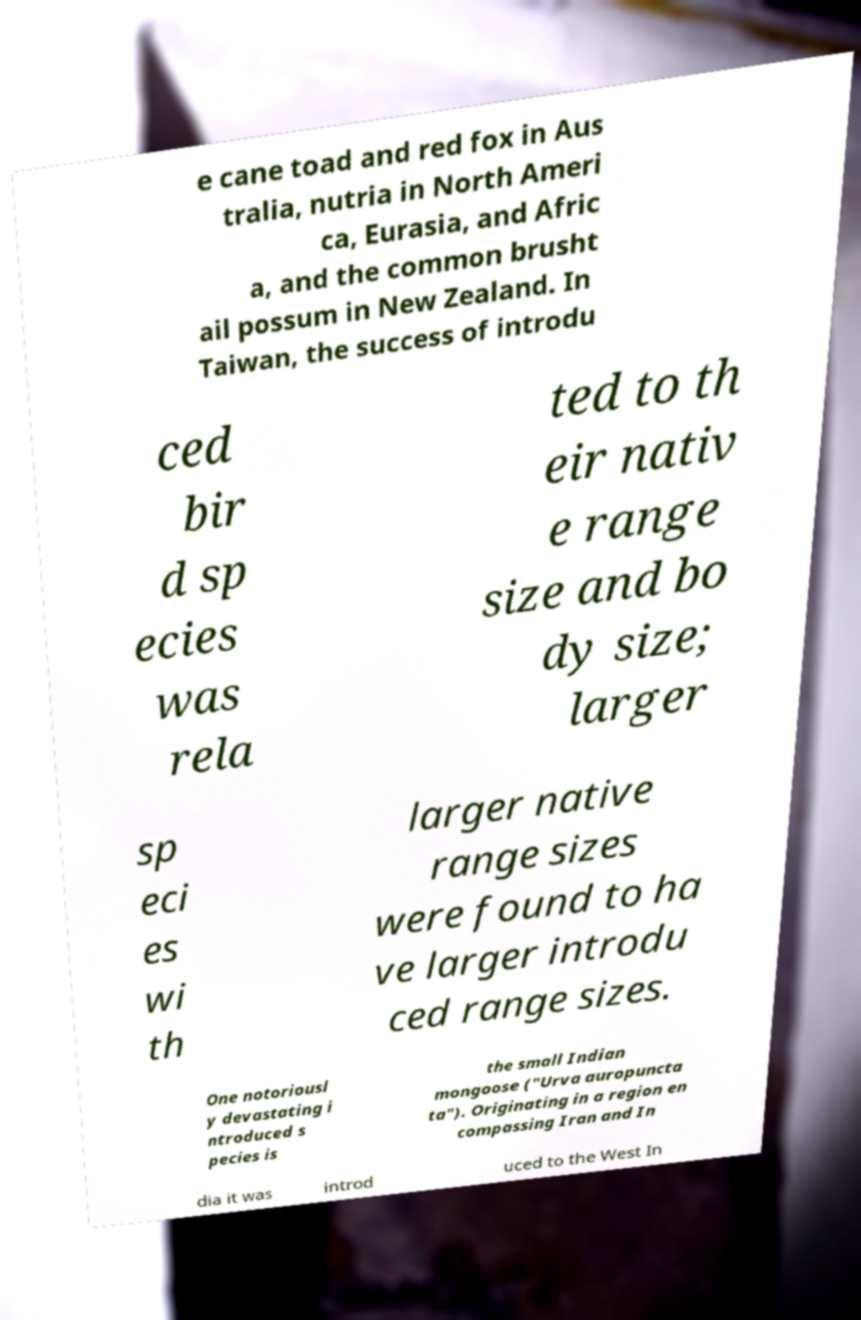Can you accurately transcribe the text from the provided image for me? e cane toad and red fox in Aus tralia, nutria in North Ameri ca, Eurasia, and Afric a, and the common brusht ail possum in New Zealand. In Taiwan, the success of introdu ced bir d sp ecies was rela ted to th eir nativ e range size and bo dy size; larger sp eci es wi th larger native range sizes were found to ha ve larger introdu ced range sizes. One notoriousl y devastating i ntroduced s pecies is the small Indian mongoose ("Urva auropuncta ta"). Originating in a region en compassing Iran and In dia it was introd uced to the West In 